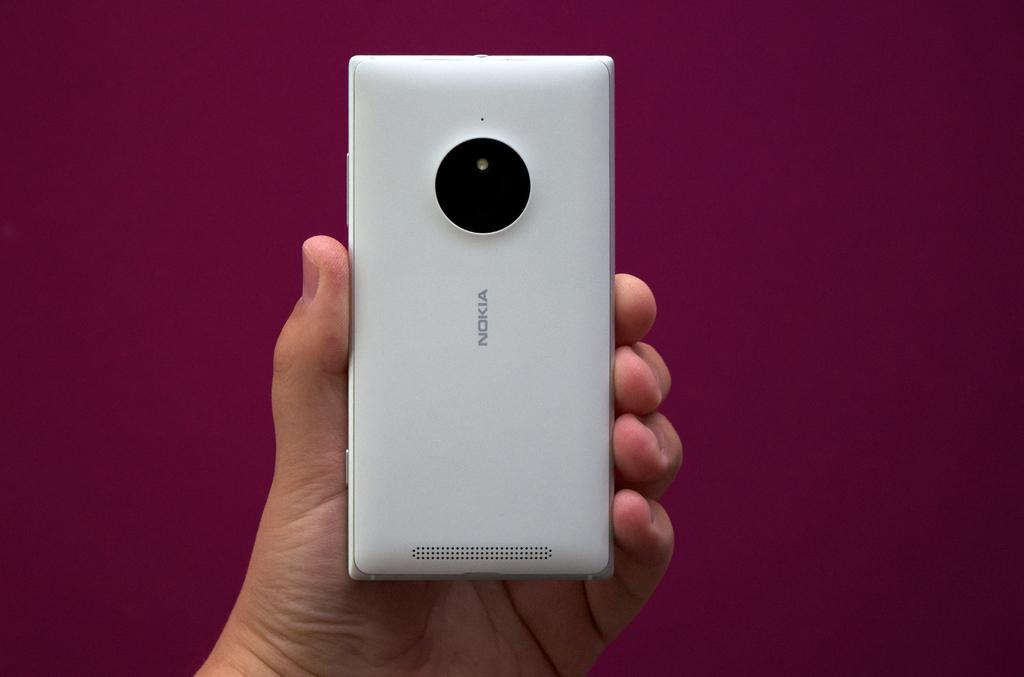<image>
Render a clear and concise summary of the photo. the word Nokia is on the white phone 